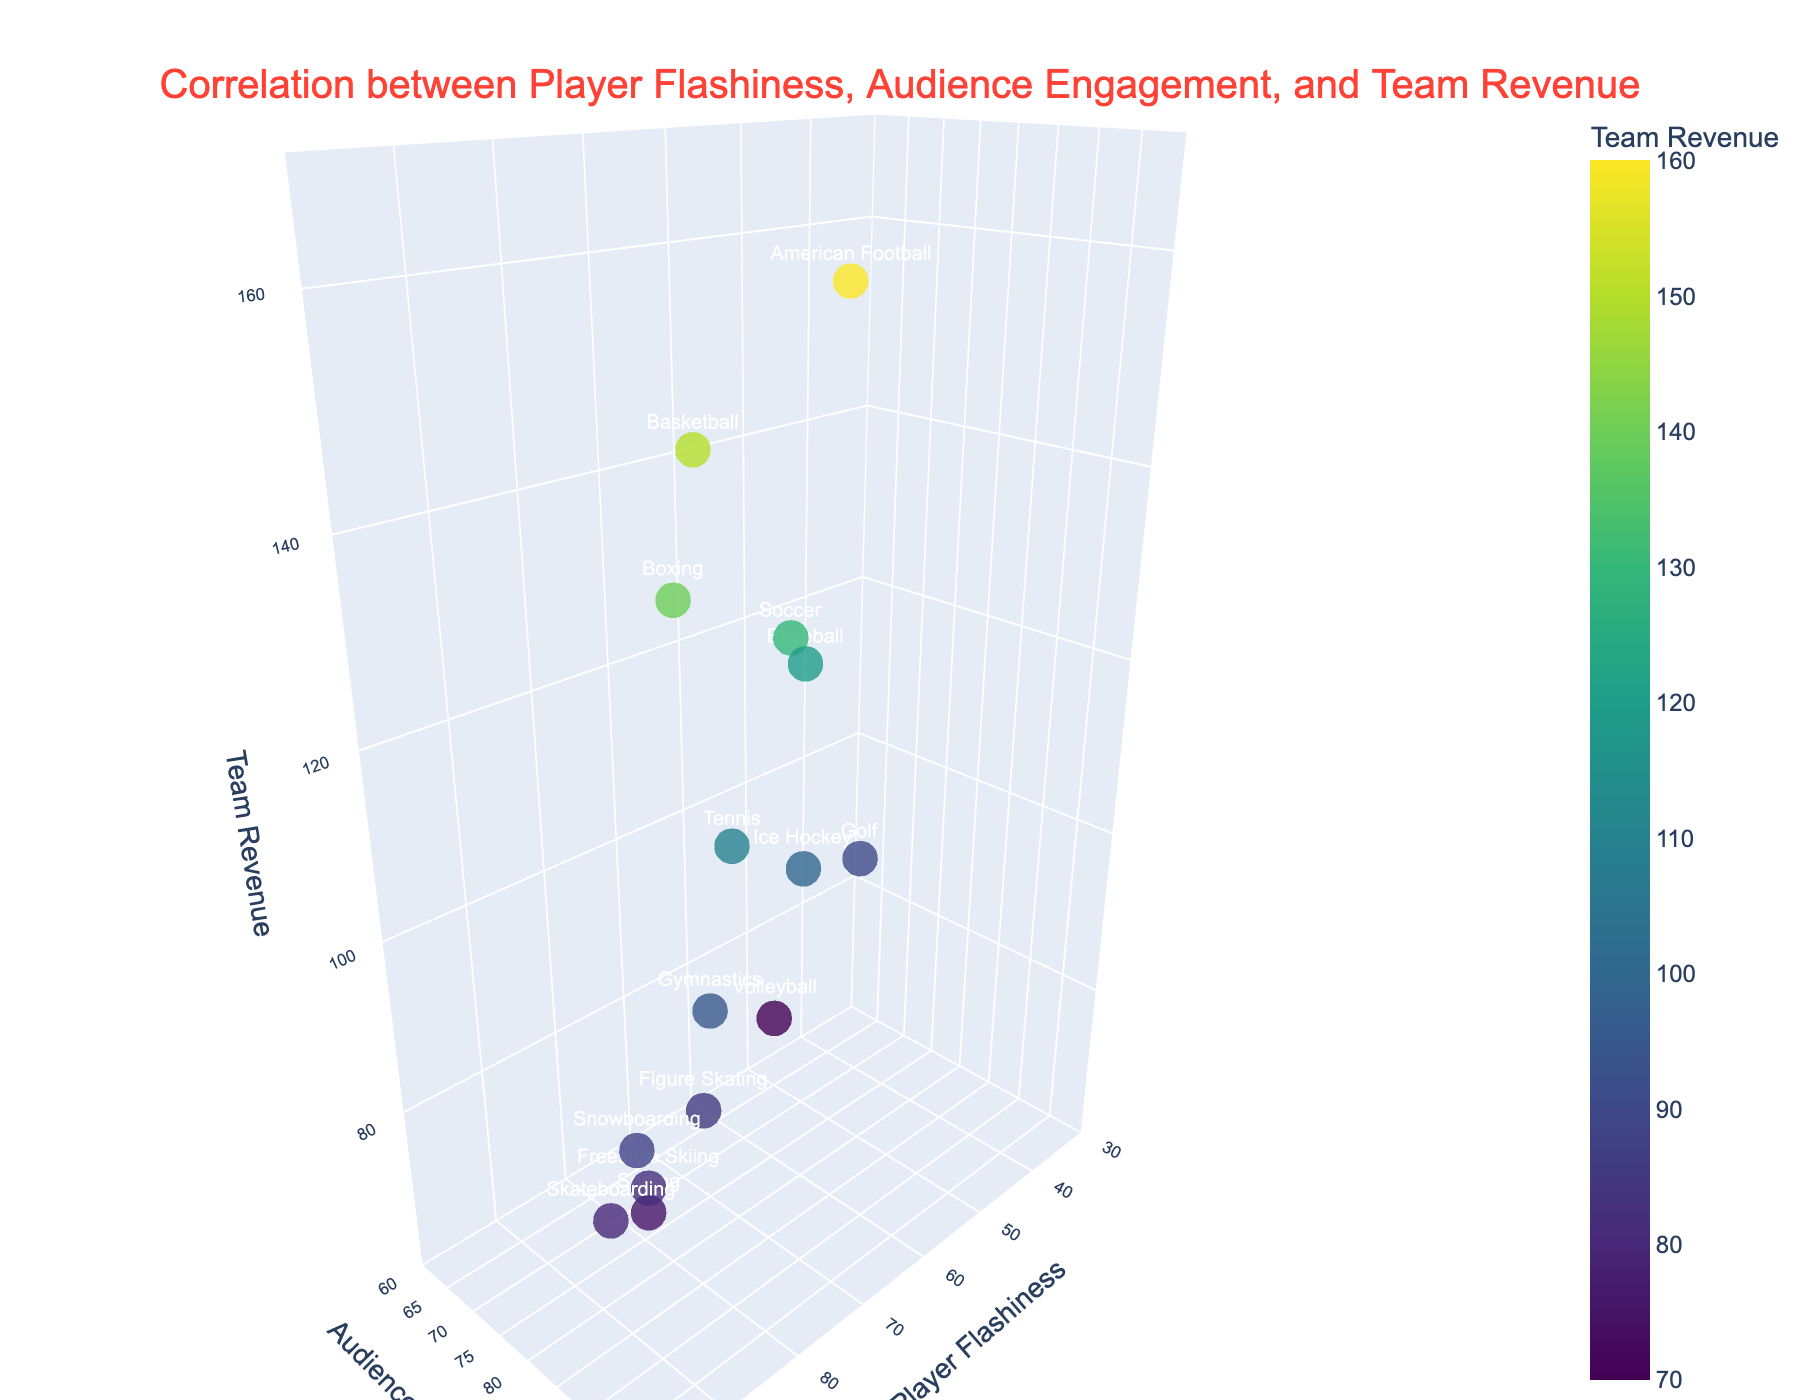What's the main title of the figure? The title of a figure is usually positioned at the top and is designed to describe the overall theme or subject of the chart. In this figure, the title is directly stated within the layout.
Answer: Correlation between Player Flashiness, Audience Engagement, and Team Revenue Which sport has the highest player flashiness? To find the sport with the highest player flashiness, look for the highest value on the Player Flashiness axis (x-axis) and find the corresponding sport label.
Answer: Skateboarding What is the team revenue of Basketball? Locate the data point for Basketball by looking at the sport labels and read off the Team Revenue value (z-axis) associated with that point.
Answer: 150 What's the average team revenue of the sports with player flashiness greater than 90? Identify the sports with player flashiness values greater than 90 (Skateboarding, Snowboarding, Freestyle Skiing). Their revenues are 80, 88, and 82. Calculate the average: (80 + 88 + 82) / 3 ≈ 83.33.
Answer: 83.33 Compare the audience engagement of Tennis and Golf. Which one is higher? Locate the data points for Tennis and Golf by their sports labels and compare their values on the Audience Engagement axis (y-axis). Tennis is 85, Golf is 70. Tennis is higher.
Answer: Tennis Which sport's data point is positioned closest to the camera? The camera's position is given by the eye parameter in the layout (x=1.5, y=1.5, z=1). Check which sport's data point has the coordinates nearest to these values.
Answer: American Football What is the color scale used for the markers? The color scale assists in visually distinguishing the data points based on the Team Revenue values. The color used in the figure is specified to be ‘Viridis’.
Answer: Viridis How many sports have a team revenue greater than 110? Look at the z-axis for Team Revenue and count the number of data points (sports) that have values above 110. These include Basketball, Soccer, American Football, and Baseball.
Answer: 4 Is there a positive trend between player flashiness and audience engagement? To determine a trend, observe the general direction of the data points when moving from lower to higher values of player flashiness and audience engagement. The points show an upward trend aligning with increased values on both axes.
Answer: Yes Which sport has a higher audience engagement: Surfing or Figure Skating? Compare the y-axis values (Audience Engagement) for Surfing and Figure Skating. Surfing has an audience engagement of 86, while Figure Skating has 88. Figure Skating is higher.
Answer: Figure Skating 